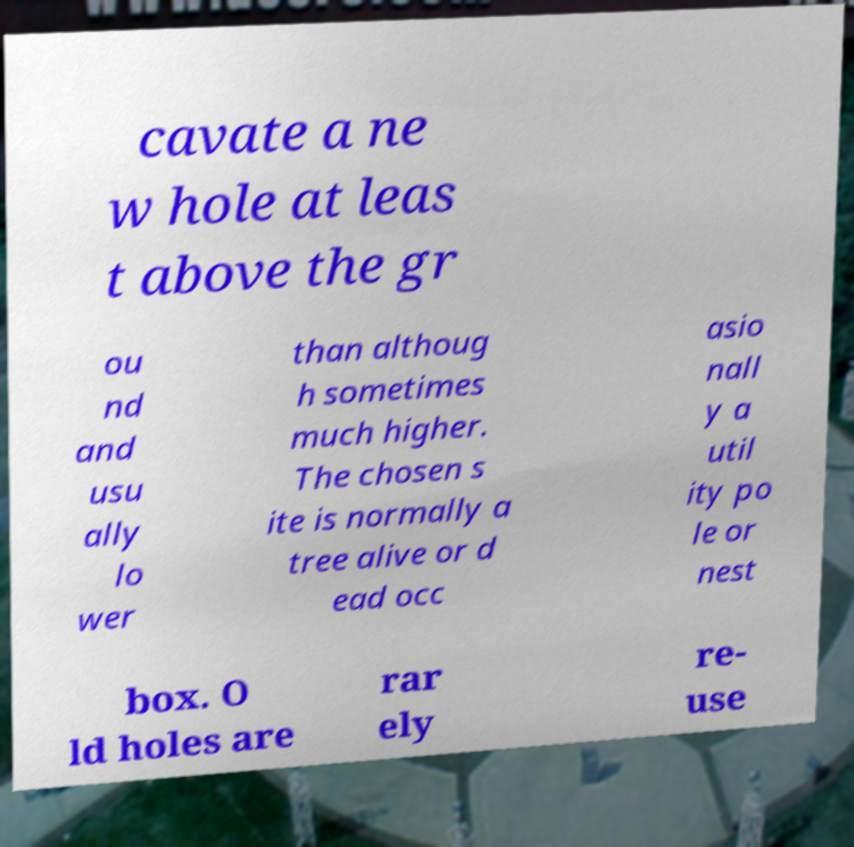There's text embedded in this image that I need extracted. Can you transcribe it verbatim? cavate a ne w hole at leas t above the gr ou nd and usu ally lo wer than althoug h sometimes much higher. The chosen s ite is normally a tree alive or d ead occ asio nall y a util ity po le or nest box. O ld holes are rar ely re- use 